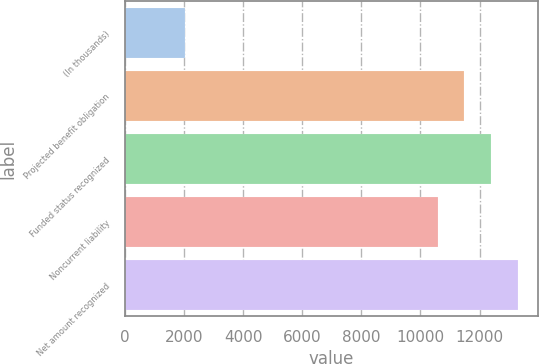Convert chart. <chart><loc_0><loc_0><loc_500><loc_500><bar_chart><fcel>(In thousands)<fcel>Projected benefit obligation<fcel>Funded status recognized<fcel>Noncurrent liability<fcel>Net amount recognized<nl><fcel>2019<fcel>11488.3<fcel>12394.6<fcel>10582<fcel>13300.9<nl></chart> 